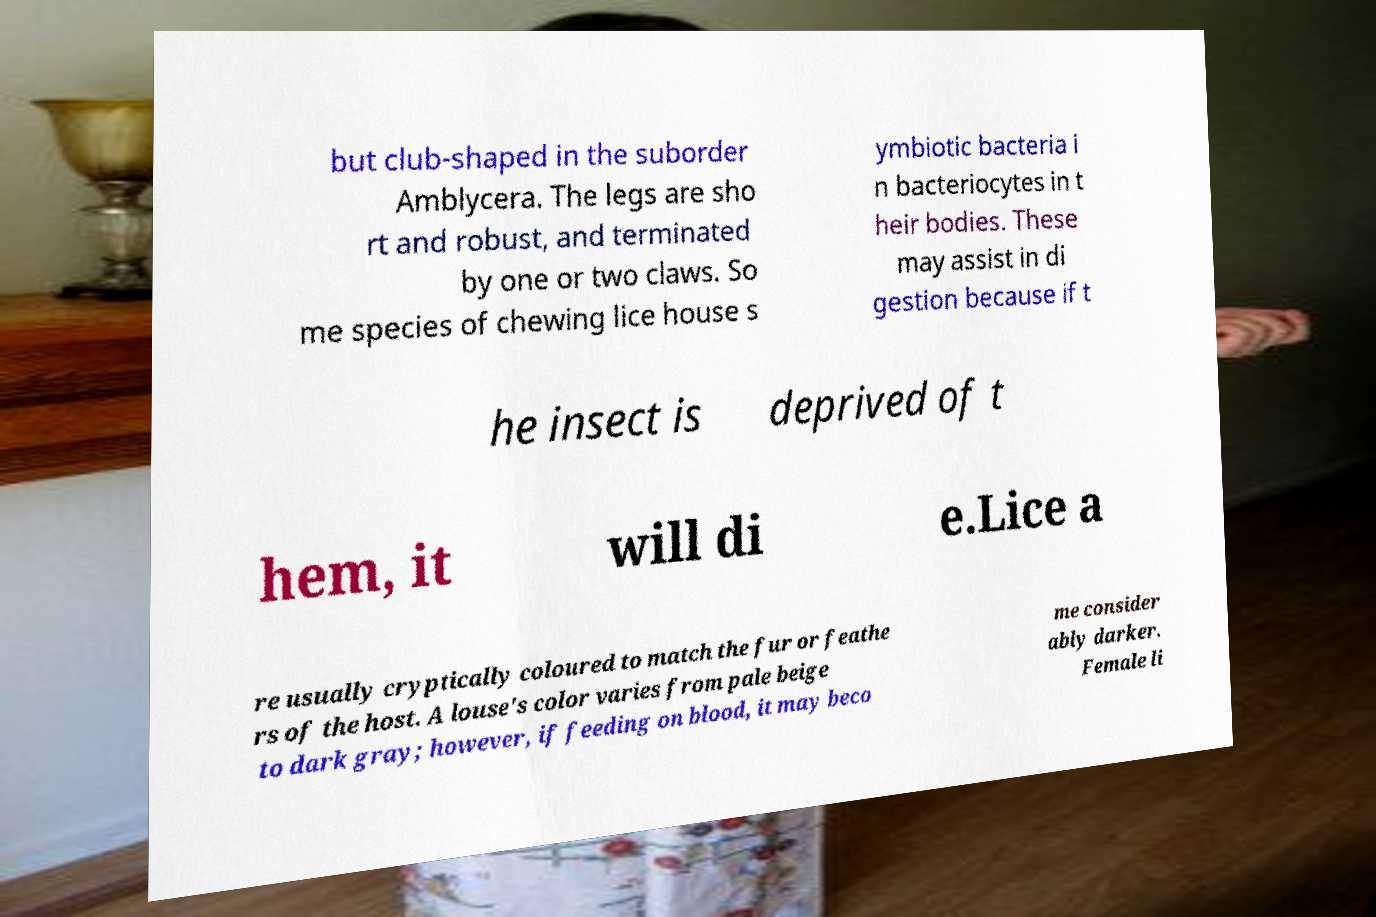Please read and relay the text visible in this image. What does it say? but club-shaped in the suborder Amblycera. The legs are sho rt and robust, and terminated by one or two claws. So me species of chewing lice house s ymbiotic bacteria i n bacteriocytes in t heir bodies. These may assist in di gestion because if t he insect is deprived of t hem, it will di e.Lice a re usually cryptically coloured to match the fur or feathe rs of the host. A louse's color varies from pale beige to dark gray; however, if feeding on blood, it may beco me consider ably darker. Female li 